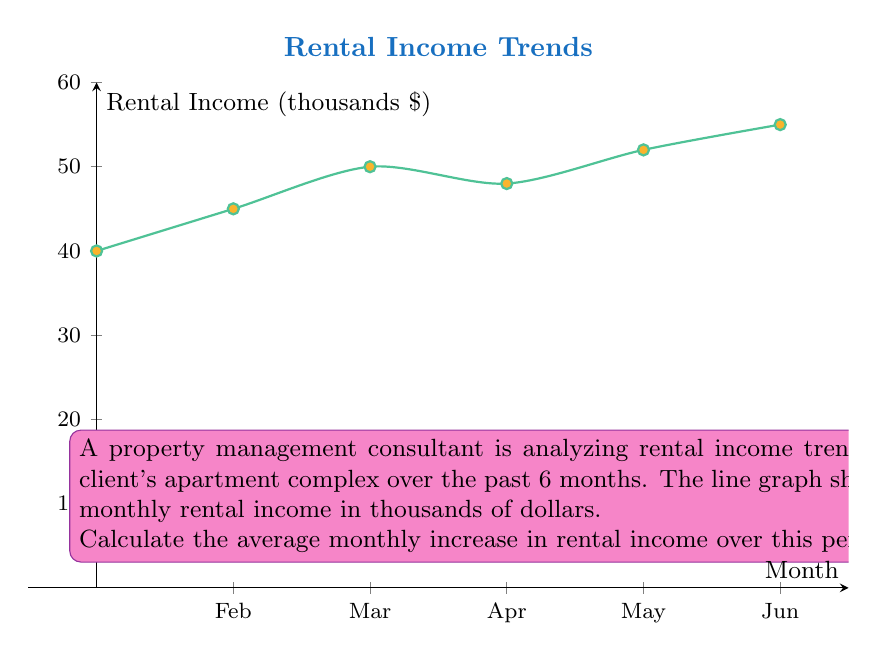Can you answer this question? To calculate the average monthly increase in rental income, we need to follow these steps:

1) First, calculate the total increase from January to June:
   June income - January income = $55,000 - $40,000 = $15,000

2) Next, determine the number of intervals between January and June:
   There are 5 intervals (Jan-Feb, Feb-Mar, Mar-Apr, Apr-May, May-Jun)

3) Calculate the average monthly increase:
   Average increase = Total increase ÷ Number of intervals
   $$\text{Average increase} = \frac{\$15,000}{5} = \$3,000$$

Therefore, the average monthly increase in rental income over this 6-month period is $3,000.
Answer: $3,000 